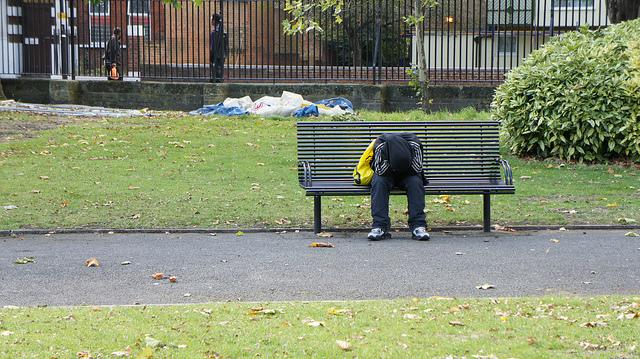Where is the head of this person?

Choices:
A) behind them
B) above shoulders
C) above knees
D) no where above knees 